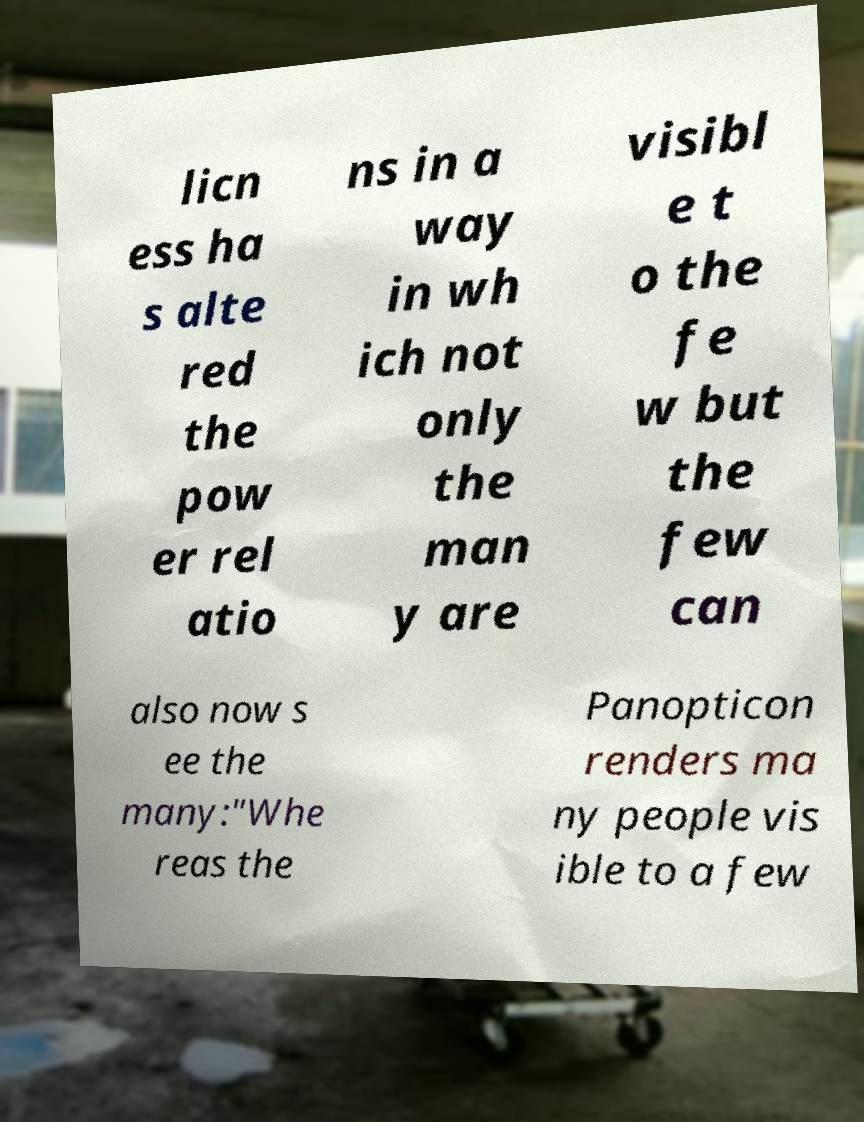For documentation purposes, I need the text within this image transcribed. Could you provide that? licn ess ha s alte red the pow er rel atio ns in a way in wh ich not only the man y are visibl e t o the fe w but the few can also now s ee the many:"Whe reas the Panopticon renders ma ny people vis ible to a few 